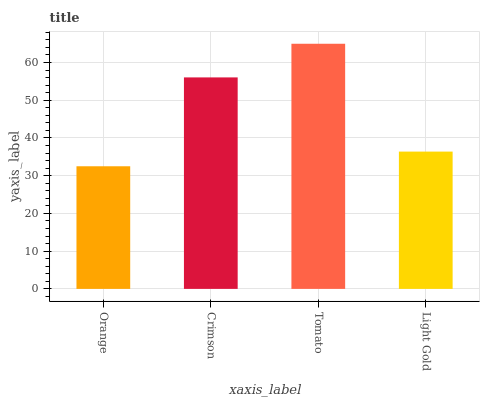Is Orange the minimum?
Answer yes or no. Yes. Is Tomato the maximum?
Answer yes or no. Yes. Is Crimson the minimum?
Answer yes or no. No. Is Crimson the maximum?
Answer yes or no. No. Is Crimson greater than Orange?
Answer yes or no. Yes. Is Orange less than Crimson?
Answer yes or no. Yes. Is Orange greater than Crimson?
Answer yes or no. No. Is Crimson less than Orange?
Answer yes or no. No. Is Crimson the high median?
Answer yes or no. Yes. Is Light Gold the low median?
Answer yes or no. Yes. Is Orange the high median?
Answer yes or no. No. Is Crimson the low median?
Answer yes or no. No. 